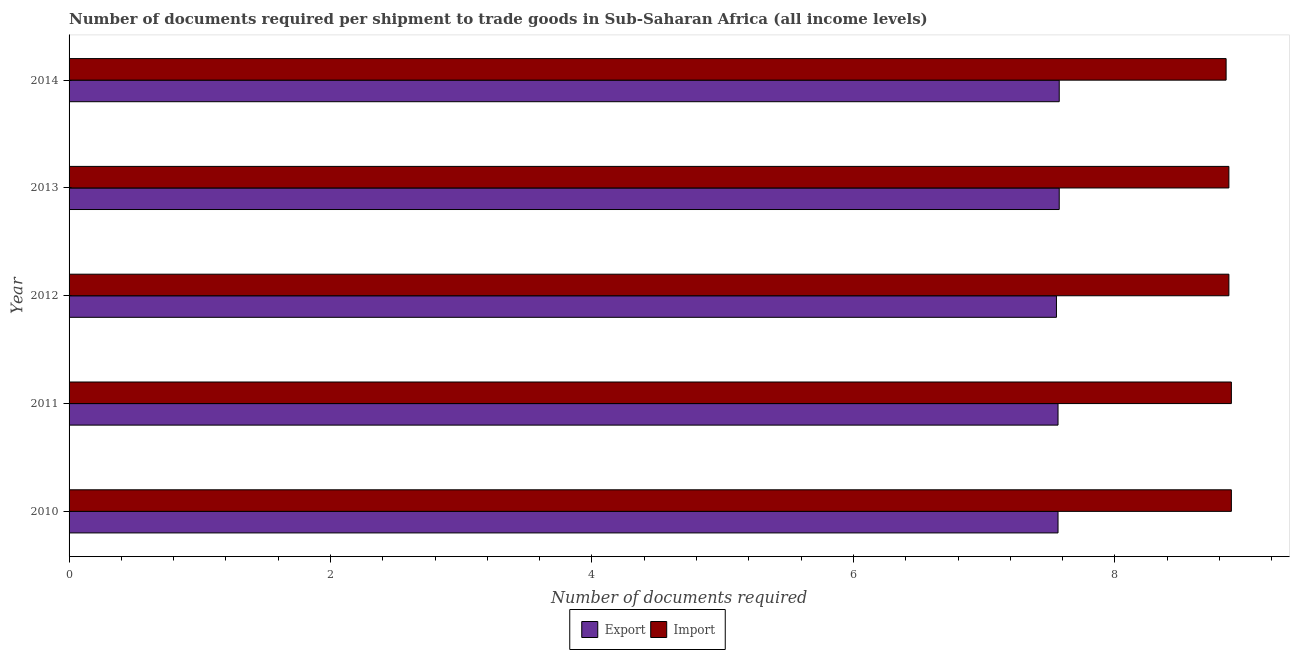How many different coloured bars are there?
Provide a short and direct response. 2. Are the number of bars per tick equal to the number of legend labels?
Your answer should be very brief. Yes. Are the number of bars on each tick of the Y-axis equal?
Make the answer very short. Yes. How many bars are there on the 4th tick from the top?
Provide a short and direct response. 2. What is the number of documents required to export goods in 2012?
Give a very brief answer. 7.55. Across all years, what is the maximum number of documents required to export goods?
Provide a succinct answer. 7.57. Across all years, what is the minimum number of documents required to export goods?
Provide a succinct answer. 7.55. In which year was the number of documents required to export goods minimum?
Provide a short and direct response. 2012. What is the total number of documents required to export goods in the graph?
Your answer should be very brief. 37.83. What is the difference between the number of documents required to export goods in 2010 and that in 2011?
Offer a very short reply. 0. What is the difference between the number of documents required to export goods in 2010 and the number of documents required to import goods in 2011?
Provide a short and direct response. -1.33. What is the average number of documents required to export goods per year?
Offer a very short reply. 7.57. In the year 2014, what is the difference between the number of documents required to export goods and number of documents required to import goods?
Give a very brief answer. -1.28. Is the difference between the number of documents required to export goods in 2011 and 2013 greater than the difference between the number of documents required to import goods in 2011 and 2013?
Offer a terse response. No. What is the difference between the highest and the lowest number of documents required to export goods?
Keep it short and to the point. 0.02. In how many years, is the number of documents required to export goods greater than the average number of documents required to export goods taken over all years?
Provide a short and direct response. 2. What does the 1st bar from the top in 2014 represents?
Provide a succinct answer. Import. What does the 1st bar from the bottom in 2014 represents?
Keep it short and to the point. Export. Are all the bars in the graph horizontal?
Keep it short and to the point. Yes. What is the difference between two consecutive major ticks on the X-axis?
Provide a short and direct response. 2. Does the graph contain grids?
Offer a terse response. No. How many legend labels are there?
Offer a very short reply. 2. What is the title of the graph?
Make the answer very short. Number of documents required per shipment to trade goods in Sub-Saharan Africa (all income levels). Does "Foreign liabilities" appear as one of the legend labels in the graph?
Offer a very short reply. No. What is the label or title of the X-axis?
Offer a very short reply. Number of documents required. What is the Number of documents required in Export in 2010?
Your response must be concise. 7.57. What is the Number of documents required of Import in 2010?
Give a very brief answer. 8.89. What is the Number of documents required in Export in 2011?
Your answer should be very brief. 7.57. What is the Number of documents required of Import in 2011?
Give a very brief answer. 8.89. What is the Number of documents required in Export in 2012?
Provide a succinct answer. 7.55. What is the Number of documents required in Import in 2012?
Provide a short and direct response. 8.87. What is the Number of documents required of Export in 2013?
Keep it short and to the point. 7.57. What is the Number of documents required in Import in 2013?
Give a very brief answer. 8.87. What is the Number of documents required in Export in 2014?
Ensure brevity in your answer.  7.57. What is the Number of documents required in Import in 2014?
Your answer should be compact. 8.85. Across all years, what is the maximum Number of documents required of Export?
Your answer should be compact. 7.57. Across all years, what is the maximum Number of documents required in Import?
Ensure brevity in your answer.  8.89. Across all years, what is the minimum Number of documents required of Export?
Give a very brief answer. 7.55. Across all years, what is the minimum Number of documents required in Import?
Make the answer very short. 8.85. What is the total Number of documents required of Export in the graph?
Provide a succinct answer. 37.83. What is the total Number of documents required of Import in the graph?
Provide a succinct answer. 44.38. What is the difference between the Number of documents required of Import in 2010 and that in 2011?
Ensure brevity in your answer.  0. What is the difference between the Number of documents required in Export in 2010 and that in 2012?
Your answer should be compact. 0.01. What is the difference between the Number of documents required of Import in 2010 and that in 2012?
Give a very brief answer. 0.02. What is the difference between the Number of documents required in Export in 2010 and that in 2013?
Your response must be concise. -0.01. What is the difference between the Number of documents required of Import in 2010 and that in 2013?
Your response must be concise. 0.02. What is the difference between the Number of documents required of Export in 2010 and that in 2014?
Your response must be concise. -0.01. What is the difference between the Number of documents required of Import in 2010 and that in 2014?
Give a very brief answer. 0.04. What is the difference between the Number of documents required of Export in 2011 and that in 2012?
Make the answer very short. 0.01. What is the difference between the Number of documents required in Import in 2011 and that in 2012?
Offer a terse response. 0.02. What is the difference between the Number of documents required in Export in 2011 and that in 2013?
Offer a terse response. -0.01. What is the difference between the Number of documents required of Import in 2011 and that in 2013?
Your response must be concise. 0.02. What is the difference between the Number of documents required of Export in 2011 and that in 2014?
Your response must be concise. -0.01. What is the difference between the Number of documents required of Import in 2011 and that in 2014?
Offer a very short reply. 0.04. What is the difference between the Number of documents required of Export in 2012 and that in 2013?
Your answer should be very brief. -0.02. What is the difference between the Number of documents required of Export in 2012 and that in 2014?
Your response must be concise. -0.02. What is the difference between the Number of documents required in Import in 2012 and that in 2014?
Your answer should be compact. 0.02. What is the difference between the Number of documents required of Import in 2013 and that in 2014?
Offer a very short reply. 0.02. What is the difference between the Number of documents required of Export in 2010 and the Number of documents required of Import in 2011?
Ensure brevity in your answer.  -1.33. What is the difference between the Number of documents required in Export in 2010 and the Number of documents required in Import in 2012?
Provide a short and direct response. -1.31. What is the difference between the Number of documents required of Export in 2010 and the Number of documents required of Import in 2013?
Your response must be concise. -1.31. What is the difference between the Number of documents required of Export in 2010 and the Number of documents required of Import in 2014?
Ensure brevity in your answer.  -1.29. What is the difference between the Number of documents required in Export in 2011 and the Number of documents required in Import in 2012?
Make the answer very short. -1.31. What is the difference between the Number of documents required of Export in 2011 and the Number of documents required of Import in 2013?
Keep it short and to the point. -1.31. What is the difference between the Number of documents required of Export in 2011 and the Number of documents required of Import in 2014?
Your answer should be compact. -1.29. What is the difference between the Number of documents required of Export in 2012 and the Number of documents required of Import in 2013?
Your response must be concise. -1.32. What is the difference between the Number of documents required in Export in 2012 and the Number of documents required in Import in 2014?
Provide a short and direct response. -1.3. What is the difference between the Number of documents required of Export in 2013 and the Number of documents required of Import in 2014?
Your response must be concise. -1.28. What is the average Number of documents required in Export per year?
Keep it short and to the point. 7.57. What is the average Number of documents required in Import per year?
Provide a succinct answer. 8.88. In the year 2010, what is the difference between the Number of documents required in Export and Number of documents required in Import?
Your answer should be compact. -1.33. In the year 2011, what is the difference between the Number of documents required in Export and Number of documents required in Import?
Ensure brevity in your answer.  -1.33. In the year 2012, what is the difference between the Number of documents required of Export and Number of documents required of Import?
Your response must be concise. -1.32. In the year 2013, what is the difference between the Number of documents required in Export and Number of documents required in Import?
Give a very brief answer. -1.3. In the year 2014, what is the difference between the Number of documents required of Export and Number of documents required of Import?
Your answer should be compact. -1.28. What is the ratio of the Number of documents required in Export in 2010 to that in 2011?
Your answer should be compact. 1. What is the ratio of the Number of documents required of Import in 2010 to that in 2011?
Make the answer very short. 1. What is the ratio of the Number of documents required in Export in 2010 to that in 2012?
Provide a succinct answer. 1. What is the ratio of the Number of documents required in Import in 2010 to that in 2012?
Offer a terse response. 1. What is the ratio of the Number of documents required in Import in 2010 to that in 2013?
Provide a succinct answer. 1. What is the ratio of the Number of documents required of Export in 2010 to that in 2014?
Provide a succinct answer. 1. What is the ratio of the Number of documents required in Import in 2010 to that in 2014?
Your answer should be compact. 1. What is the ratio of the Number of documents required in Export in 2011 to that in 2012?
Keep it short and to the point. 1. What is the ratio of the Number of documents required in Export in 2011 to that in 2013?
Offer a very short reply. 1. What is the ratio of the Number of documents required in Export in 2012 to that in 2014?
Your response must be concise. 1. What is the ratio of the Number of documents required in Import in 2012 to that in 2014?
Offer a terse response. 1. What is the difference between the highest and the second highest Number of documents required in Export?
Make the answer very short. 0. What is the difference between the highest and the lowest Number of documents required in Export?
Your response must be concise. 0.02. What is the difference between the highest and the lowest Number of documents required of Import?
Provide a short and direct response. 0.04. 